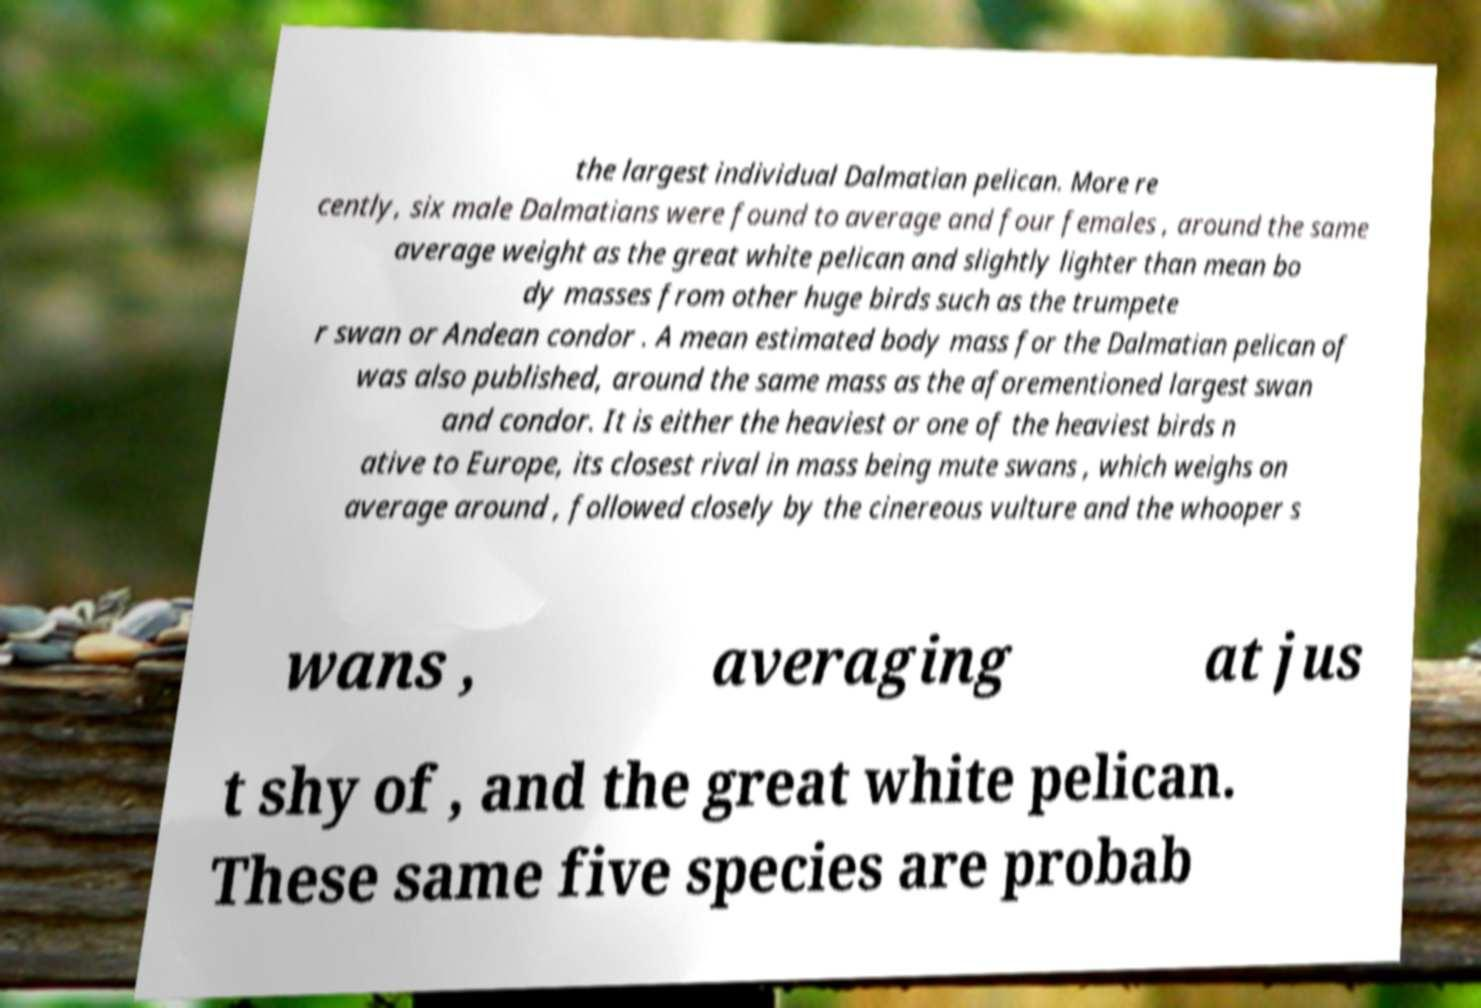There's text embedded in this image that I need extracted. Can you transcribe it verbatim? the largest individual Dalmatian pelican. More re cently, six male Dalmatians were found to average and four females , around the same average weight as the great white pelican and slightly lighter than mean bo dy masses from other huge birds such as the trumpete r swan or Andean condor . A mean estimated body mass for the Dalmatian pelican of was also published, around the same mass as the aforementioned largest swan and condor. It is either the heaviest or one of the heaviest birds n ative to Europe, its closest rival in mass being mute swans , which weighs on average around , followed closely by the cinereous vulture and the whooper s wans , averaging at jus t shy of , and the great white pelican. These same five species are probab 